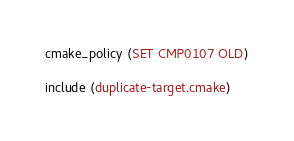<code> <loc_0><loc_0><loc_500><loc_500><_CMake_>
cmake_policy (SET CMP0107 OLD)

include (duplicate-target.cmake)
</code> 